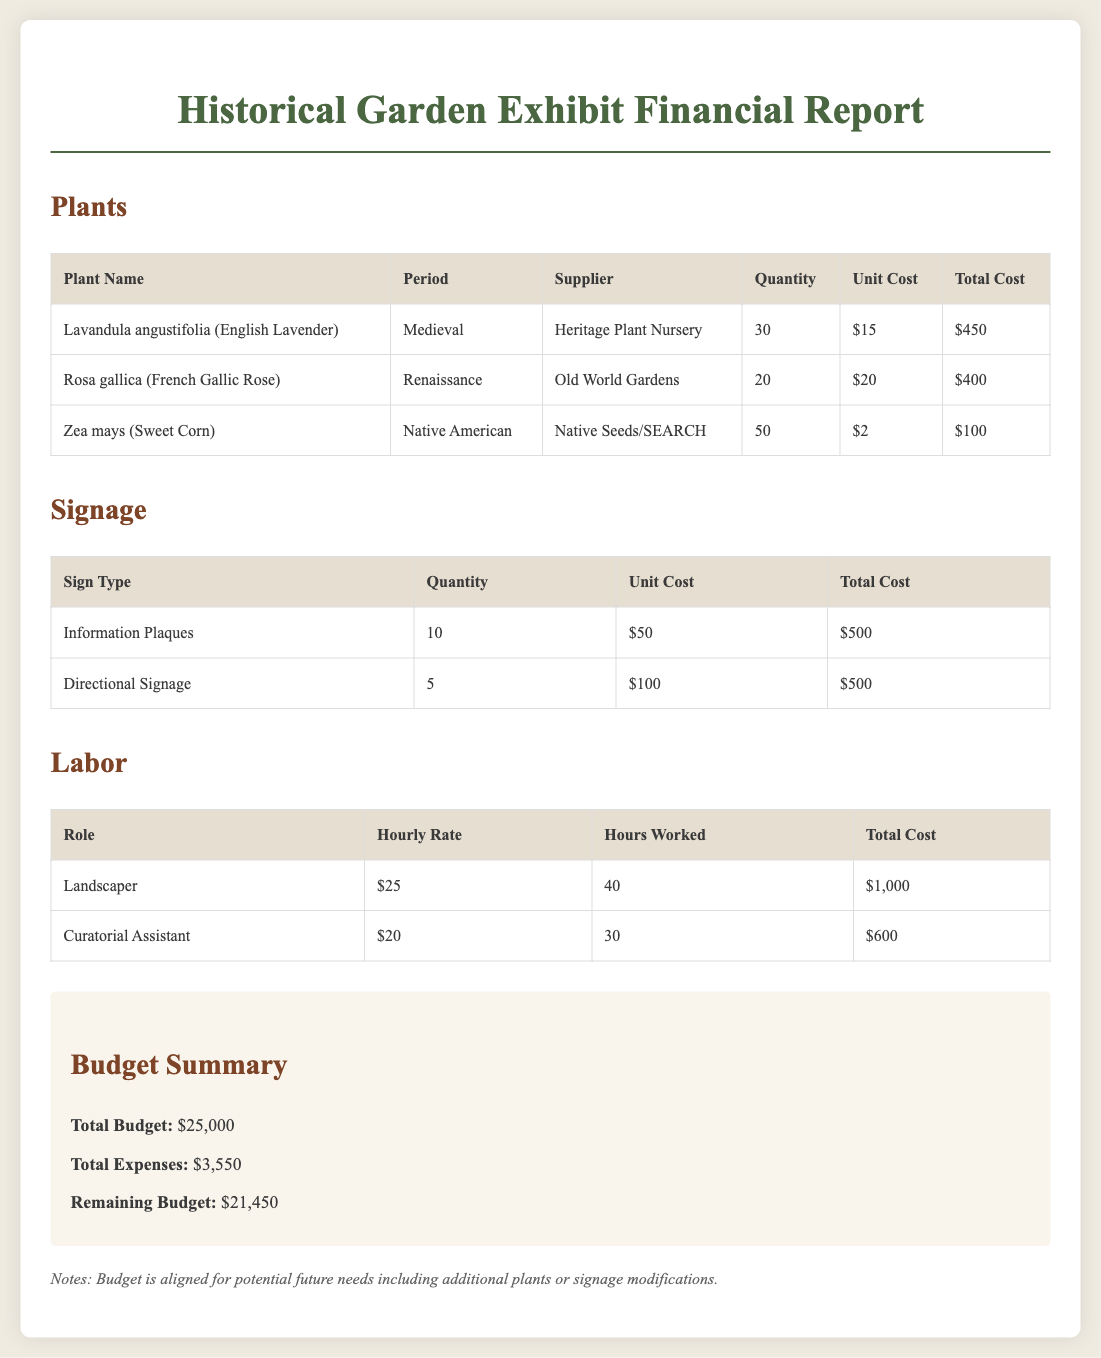What is the total cost for plants? The total cost for plants is calculated by summing the total costs for all plants listed in the document, which are $450 + $400 + $100 = $950.
Answer: $950 How many French Gallic Roses are purchased? The quantity of French Gallic Roses is specified in the plant table, which shows that 20 are purchased.
Answer: 20 What is the unit cost for Directional Signage? The unit cost for Directional Signage is found in the signage table, which indicates it costs $100 each.
Answer: $100 What is the hourly rate of the Landscaper? The hourly rate for the Landscaper is detailed in the labor table, showing it is $25 per hour.
Answer: $25 What is the remaining budget for the exhibit? The remaining budget is calculated by subtracting total expenses from total budget, which is $25,000 - $3,550 = $21,450.
Answer: $21,450 What is the total cost for signage? The total cost for signage is the sum of the total costs for all signage types, which are $500 + $500 = $1000.
Answer: $1000 How many hours did the Curatorial Assistant work? The hours worked by the Curatorial Assistant are listed in the labor table, which indicates they worked 30 hours.
Answer: 30 What period does Lavandula angustifolia belong to? The period for Lavandula angustifolia is mentioned in the plant table, indicating it belongs to the Medieval period.
Answer: Medieval What is the total expenses for the exhibit? The total expenses are summarized in the budget summary section, which clearly states the total expenses are $3,550.
Answer: $3,550 